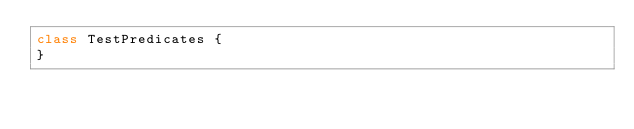Convert code to text. <code><loc_0><loc_0><loc_500><loc_500><_Kotlin_>class TestPredicates {
}</code> 